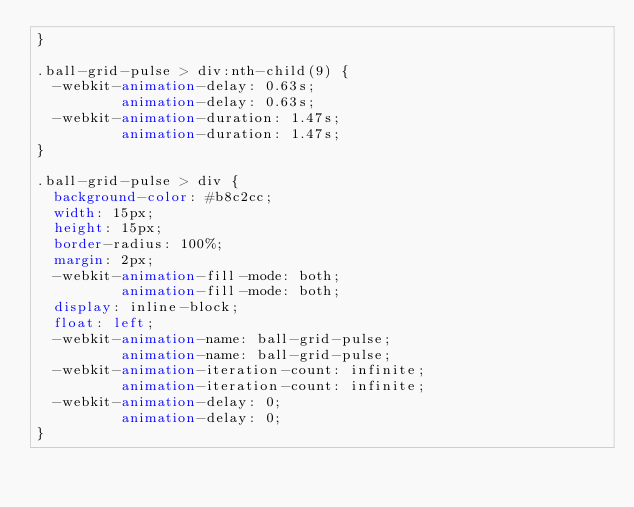Convert code to text. <code><loc_0><loc_0><loc_500><loc_500><_CSS_>}

.ball-grid-pulse > div:nth-child(9) {
  -webkit-animation-delay: 0.63s;
          animation-delay: 0.63s;
  -webkit-animation-duration: 1.47s;
          animation-duration: 1.47s;
}

.ball-grid-pulse > div {
  background-color: #b8c2cc;
  width: 15px;
  height: 15px;
  border-radius: 100%;
  margin: 2px;
  -webkit-animation-fill-mode: both;
          animation-fill-mode: both;
  display: inline-block;
  float: left;
  -webkit-animation-name: ball-grid-pulse;
          animation-name: ball-grid-pulse;
  -webkit-animation-iteration-count: infinite;
          animation-iteration-count: infinite;
  -webkit-animation-delay: 0;
          animation-delay: 0;
}

</code> 